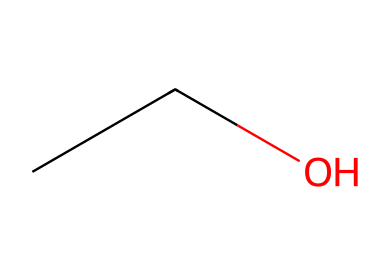What is the name of this chemical? The SMILES representation "CCO" corresponds to ethanol, which is commonly found in alcoholic beverages including beer.
Answer: ethanol How many carbon atoms are in this compound? The "CC" in the SMILES indicates two carbon atoms are present in the structure of ethanol.
Answer: two What is the functional group present in this molecule? The "OH" at the end of the SMILES representation indicates the presence of a hydroxyl group, which characterizes ethanol as an alcohol.
Answer: hydroxyl Which type of bonding is primarily observed in this compound? The carbon atoms in ethanol are connected by single (sigma) bonds, while the bond between the carbon and oxygen involves both a sigma and a pi bond. This indicates a predominance of covalent bonding within the compound.
Answer: covalent What is the molecular formula of this compound? From the SMILES composition, we find 2 carbon atoms, 6 hydrogen atoms, and 1 oxygen atom, leading to the molecular formula C2H6O.
Answer: C2H6O What does the presence of the hydroxyl group indicate about this compound's properties? The presence of the hydroxyl group decreases the compound's volatility and increases its solubility in water, contributing to its properties as an alcohol.
Answer: increases solubility Is this compound a coordination compound? Ethanol does not possess a central metal atom bonded to surrounding ligands, which are characteristics of coordination compounds; therefore, it is not classified as one.
Answer: no 